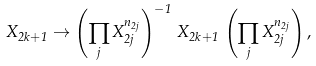Convert formula to latex. <formula><loc_0><loc_0><loc_500><loc_500>X _ { 2 k + 1 } \rightarrow \left ( \prod _ { j } X _ { 2 j } ^ { n _ { 2 j } } \right ) ^ { - 1 } \, X _ { 2 k + 1 } \, \left ( \prod _ { j } X _ { 2 j } ^ { n _ { 2 j } } \right ) ,</formula> 